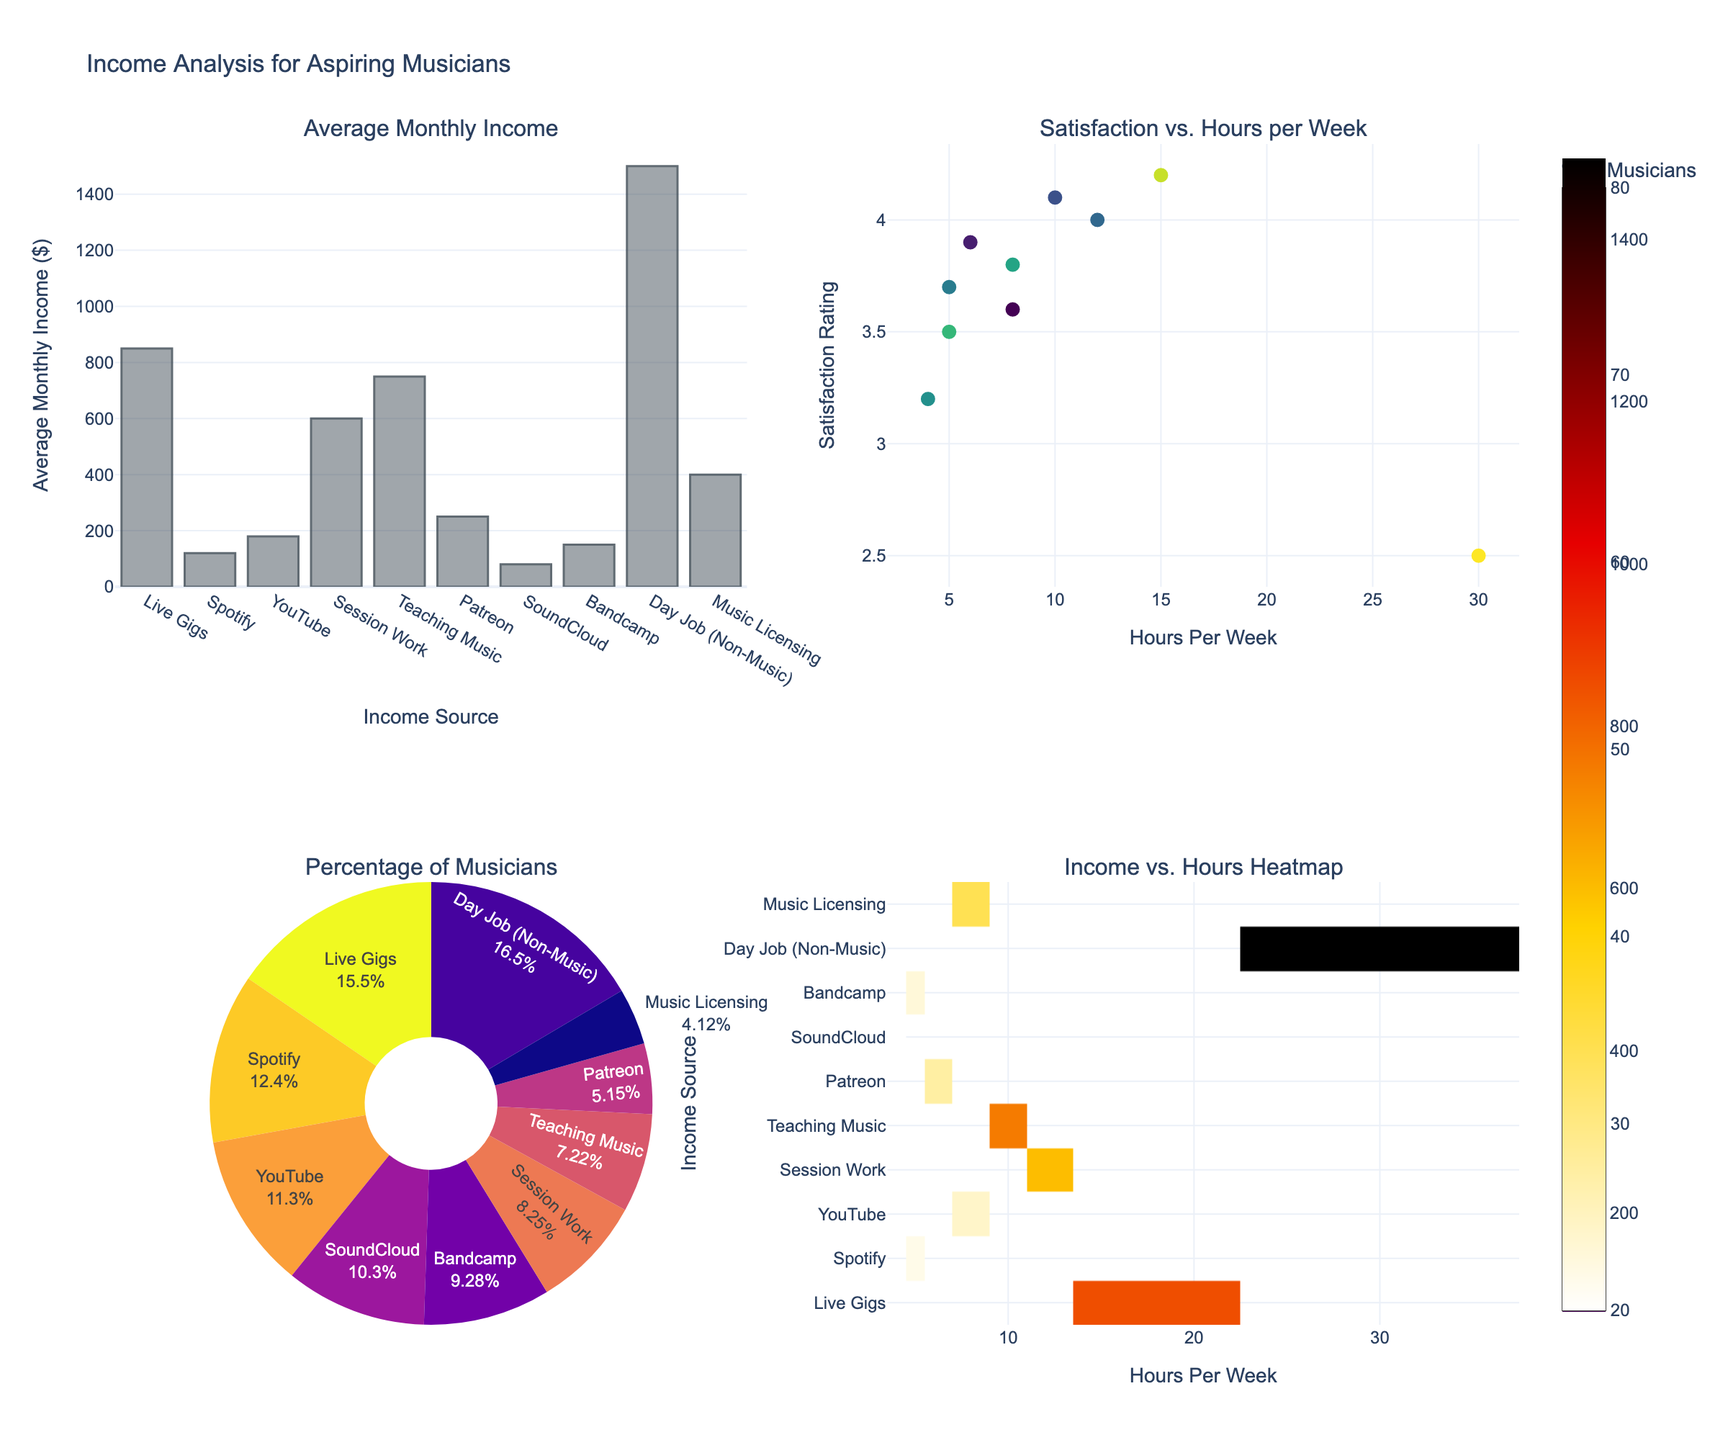What is the average monthly income for musicians from teaching music? We look at the bar chart titled "Average Monthly Income." The bar labeled "Teaching Music" shows the value corresponding to average monthly income.
Answer: $750 Which income source involves the highest number of hours per week? Referring to the scatter plot and heatmap, we identify that the highest number of hours per week falls under "Day Job (Non-Music)," which shows 30 hours per week.
Answer: Day Job (Non-Music) How is the satisfaction rating correlated with hours per week among musicians? The scatter plot titled "Satisfaction vs. Hours per Week" indicates that the satisfaction rating varies as hours per week increase. We observe that generally, satisfaction ratings cluster around 3.5 to 4.2 for fewer hours but drop significantly for "Day Job (Non-Music)" at 2.5 satisfaction with 30 hours per week.
Answer: Generally, higher hours per week correlate with lower satisfaction Which income source is the second most common among the musicians? In the pie chart titled "Percentage of Musicians," the second-largest slice represents "Live Gigs" with 75% of musicians.
Answer: Live Gigs Compare the average monthly income from Spotify and YouTube. Which one is higher and by how much? Observing the bar chart, Spotify's average monthly income is $120, while YouTube's is $180. The difference is calculated as $180 - $120.
Answer: YouTube; $60 Are musicians more satisfied with Patreon or SoundCloud based on the satisfaction rating? Referencing the scatter plot, Patreon shows a satisfaction rating of 3.9, whereas SoundCloud shows a satisfaction rating of 3.2.
Answer: Patreon Which income source has the least percentage of musicians and what is that percentage? The smallest slice in the pie chart corresponds to "Music Licensing," which shows 20%.
Answer: Music Licensing; 20% Which income source yields the highest average monthly income? Examining the bar chart, "Day Job (Non-Music)" exhibits the highest average monthly income at $1500.
Answer: Day Job (Non-Music) Identify the income source with the highest satisfaction rating and state its value. The scatter plot shows the highest satisfaction rating at 4.2, related to "Live Gigs."
Answer: Live Gigs; 4.2 How does SoundCloud's average monthly income compare to Bandcamp's? From the bar chart, SoundCloud's average monthly income is $80, while Bandcamp's is $150. Comparatively, Bandcamp's income is higher by $70.
Answer: Bandcamp; $70 